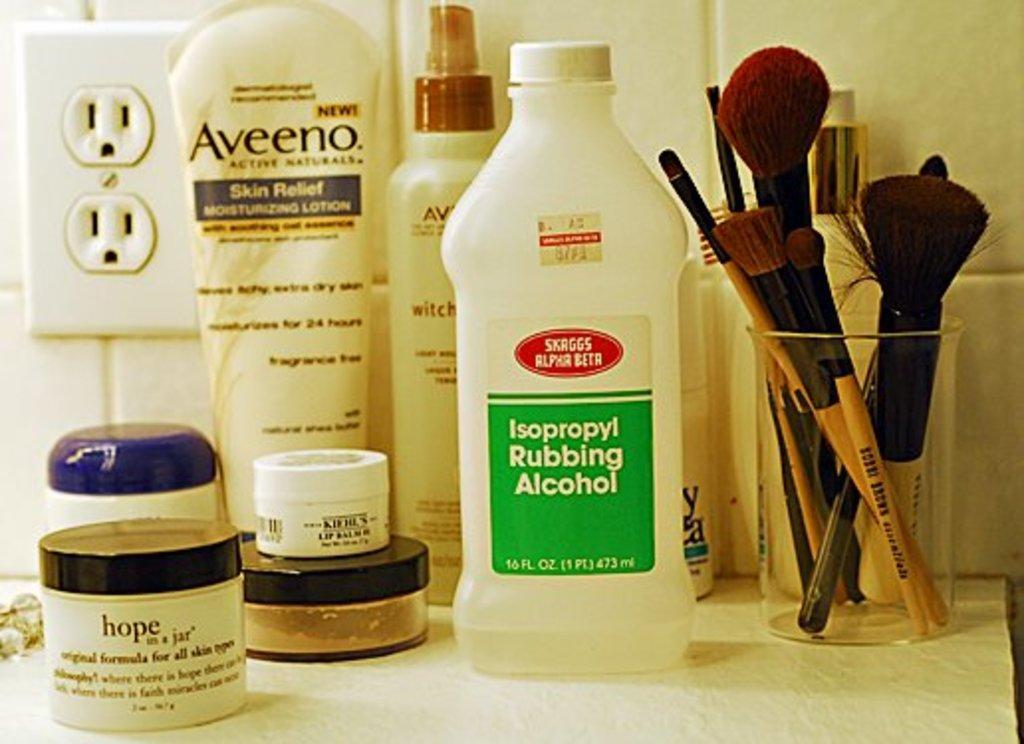Could you give a brief overview of what you see in this image? In this image we can see some soap products, lotions and some makeup powders, brushes which are on the table. 